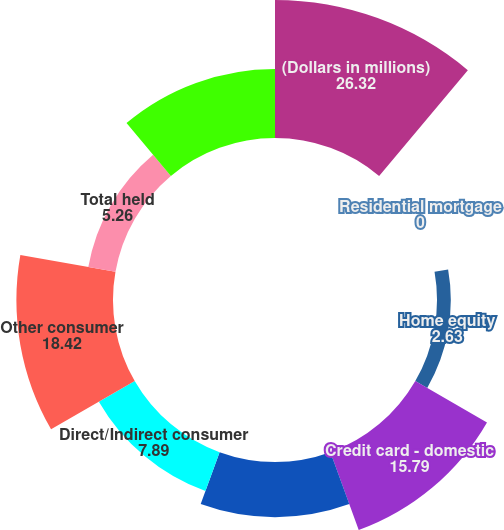<chart> <loc_0><loc_0><loc_500><loc_500><pie_chart><fcel>(Dollars in millions)<fcel>Residential mortgage<fcel>Home equity<fcel>Credit card - domestic<fcel>Credit card - foreign<fcel>Direct/Indirect consumer<fcel>Other consumer<fcel>Total held<fcel>Total credit card - managed<nl><fcel>26.32%<fcel>0.0%<fcel>2.63%<fcel>15.79%<fcel>10.53%<fcel>7.89%<fcel>18.42%<fcel>5.26%<fcel>13.16%<nl></chart> 